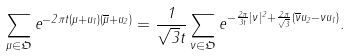<formula> <loc_0><loc_0><loc_500><loc_500>\sum _ { \mu \in \mathfrak { O } } e ^ { - 2 \pi t ( \mu + u _ { 1 } ) ( \overline { \mu } + u _ { 2 } ) } = \frac { 1 } { \sqrt { 3 } t } \sum _ { \nu \in \mathfrak { O } } e ^ { - \frac { 2 \pi } { 3 t } | \nu | ^ { 2 } + \frac { 2 \pi } { \sqrt { 3 } } ( \overline { \nu } u _ { 2 } - \nu u _ { 1 } ) } .</formula> 